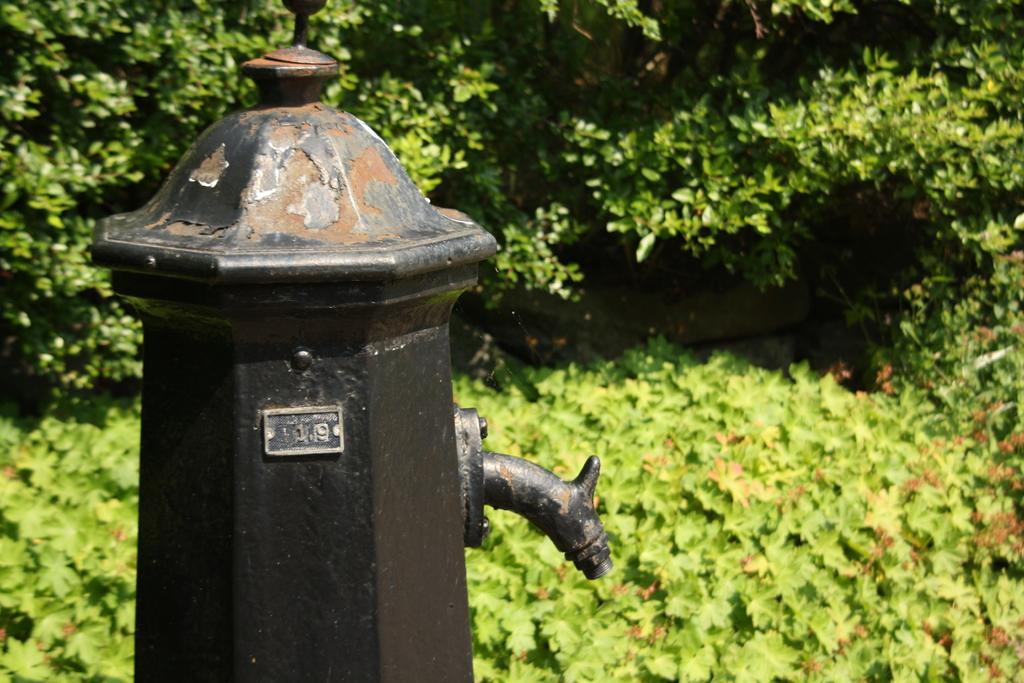Can you describe this image briefly? In this image we can see a black color pole with a pipe. In the background there are plants and trees. 